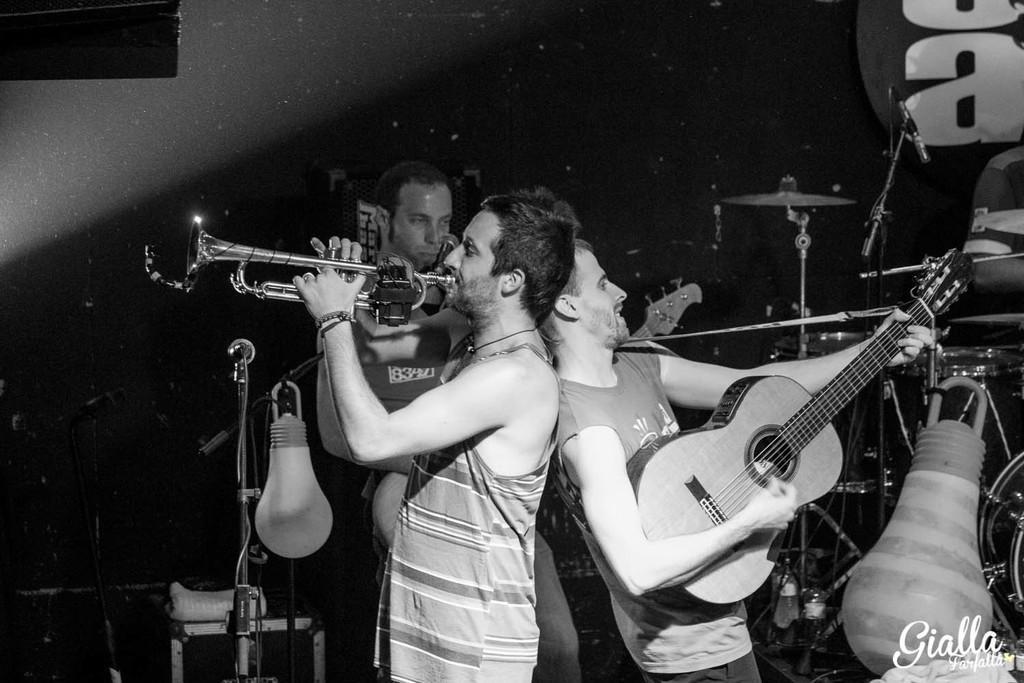In one or two sentences, can you explain what this image depicts? They are standing and they are playing musical instruments. 